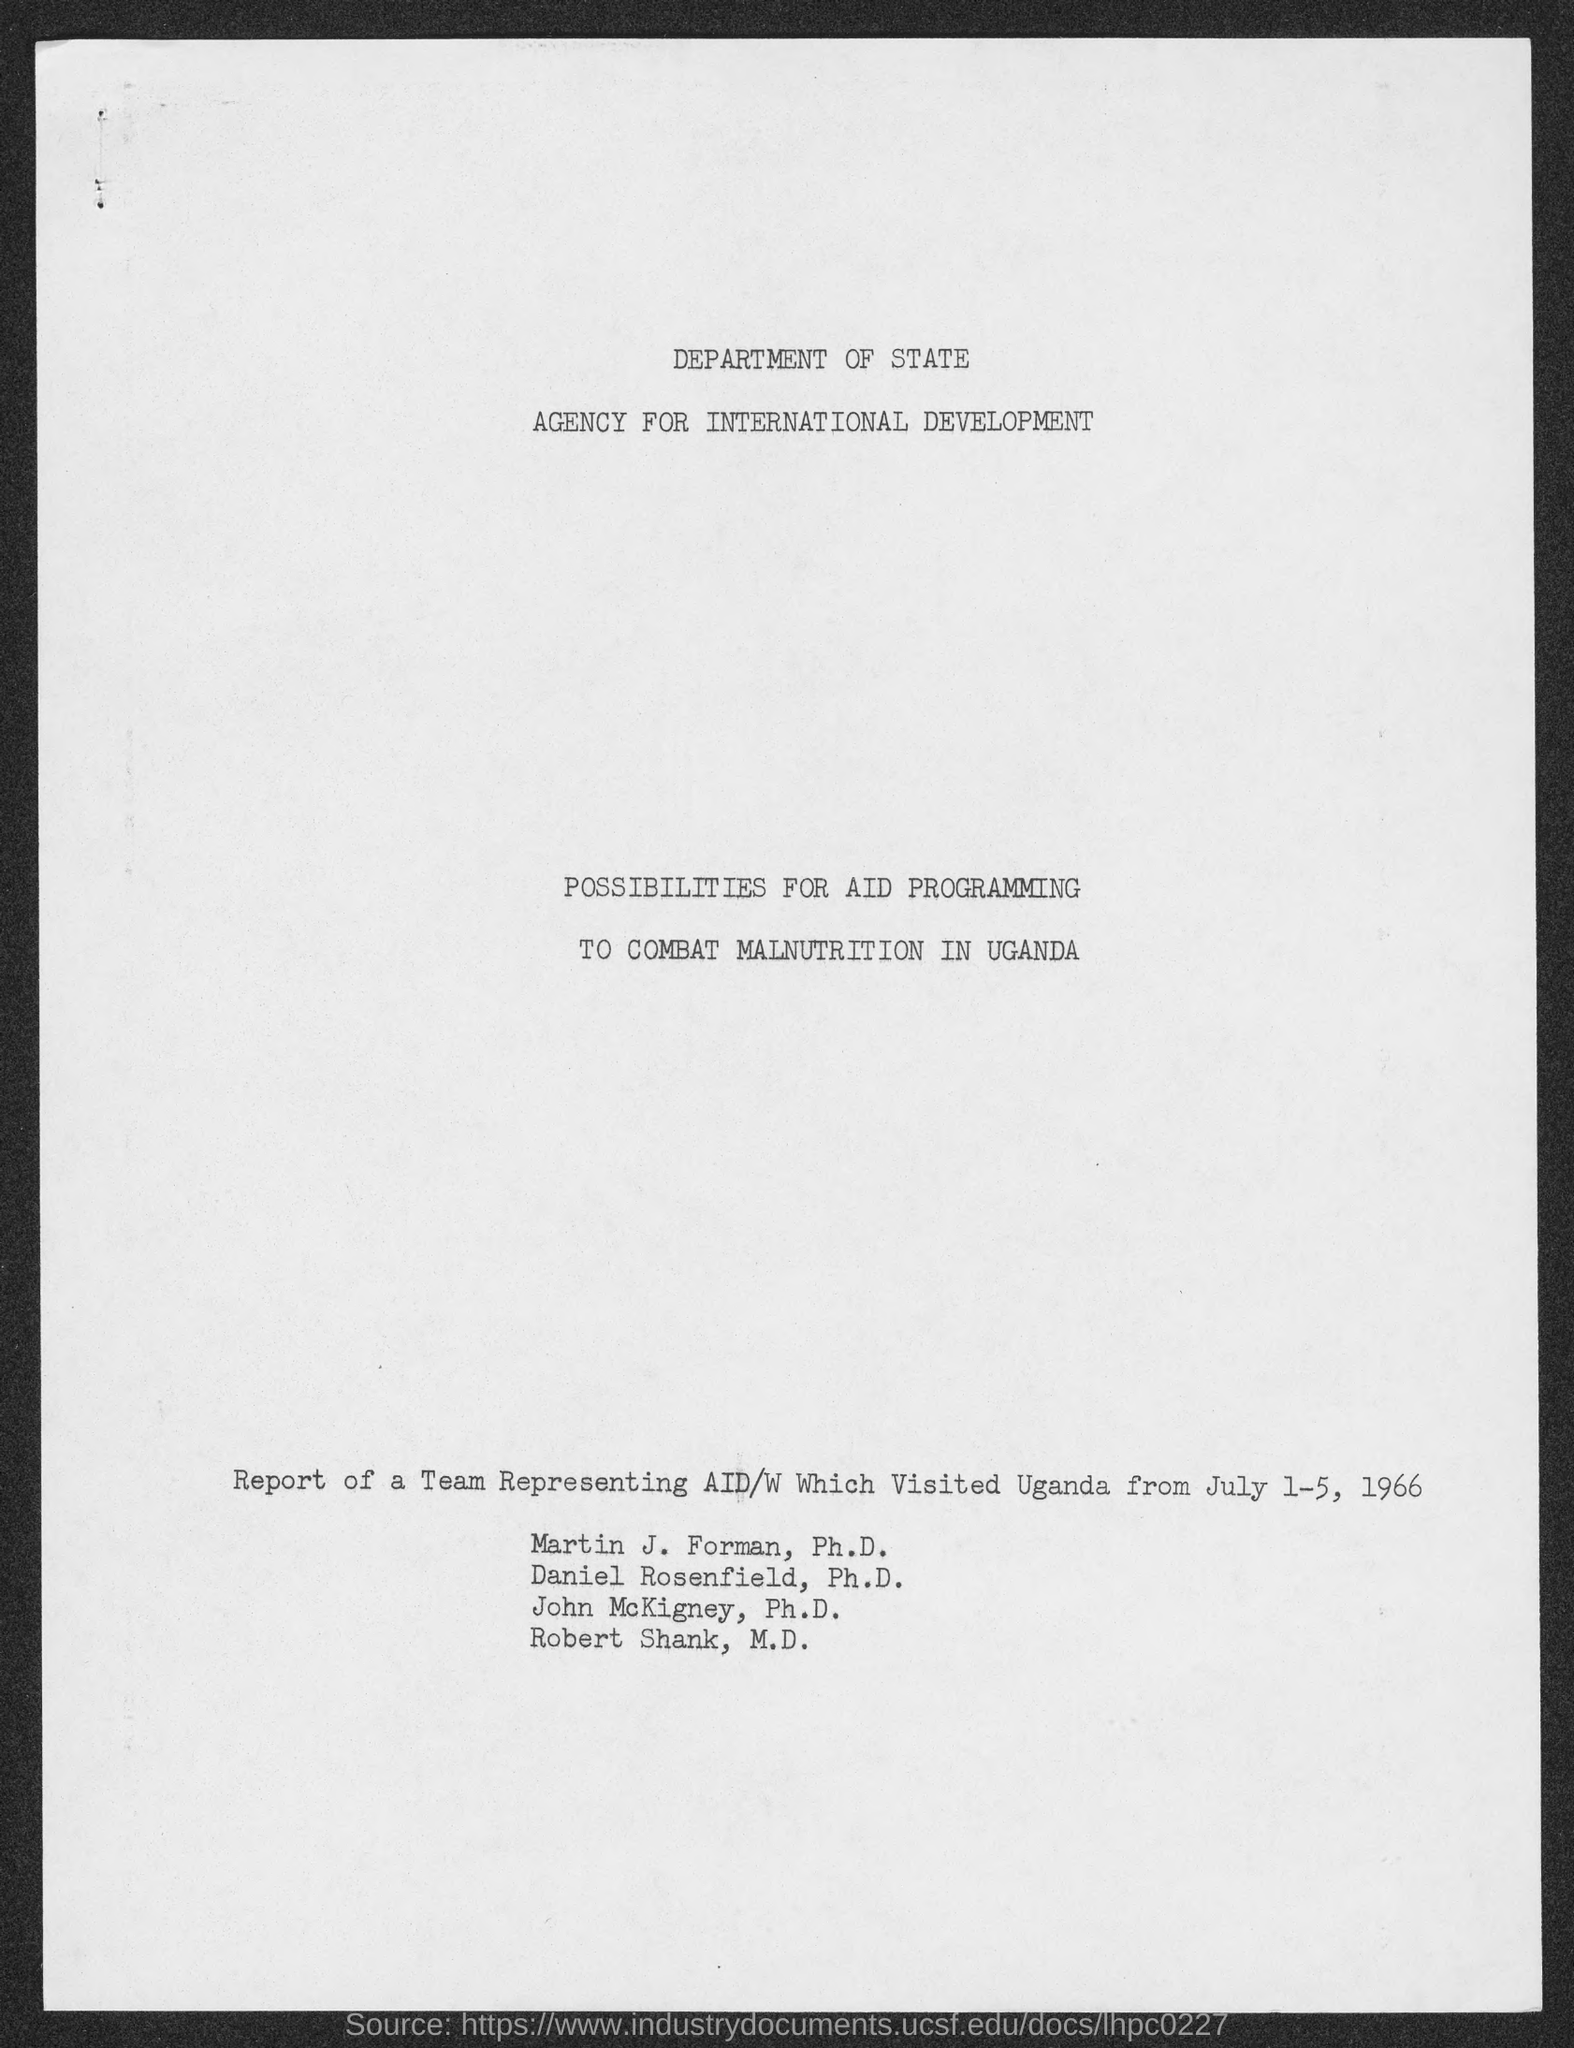Point out several critical features in this image. Martin J. Forman holds a Ph.D. in [field of study]. Robert Shank has the qualification of being an M.D. A team representing AID/W visited Uganda from July 1 to 5, 1966. The report was published by the Department of State. John McKigney holds a Ph.D. qualification. 